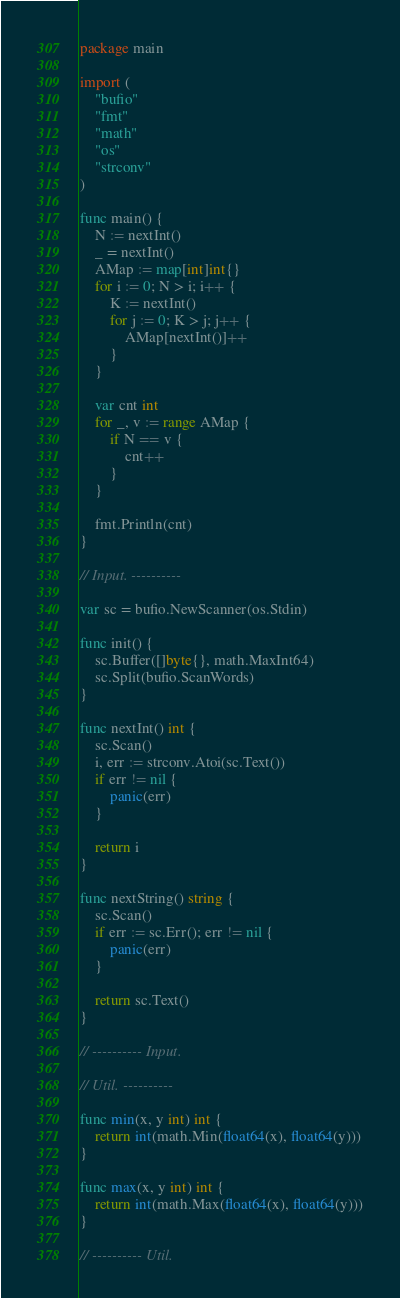Convert code to text. <code><loc_0><loc_0><loc_500><loc_500><_Go_>package main

import (
	"bufio"
	"fmt"
	"math"
	"os"
	"strconv"
)

func main() {
	N := nextInt()
	_ = nextInt()
	AMap := map[int]int{}
	for i := 0; N > i; i++ {
		K := nextInt()
		for j := 0; K > j; j++ {
			AMap[nextInt()]++
		}
	}

	var cnt int
	for _, v := range AMap {
		if N == v {
			cnt++
		}
	}

	fmt.Println(cnt)
}

// Input. ----------

var sc = bufio.NewScanner(os.Stdin)

func init() {
	sc.Buffer([]byte{}, math.MaxInt64)
	sc.Split(bufio.ScanWords)
}

func nextInt() int {
	sc.Scan()
	i, err := strconv.Atoi(sc.Text())
	if err != nil {
		panic(err)
	}

	return i
}

func nextString() string {
	sc.Scan()
	if err := sc.Err(); err != nil {
		panic(err)
	}

	return sc.Text()
}

// ---------- Input.

// Util. ----------

func min(x, y int) int {
	return int(math.Min(float64(x), float64(y)))
}

func max(x, y int) int {
	return int(math.Max(float64(x), float64(y)))
}

// ---------- Util.
</code> 